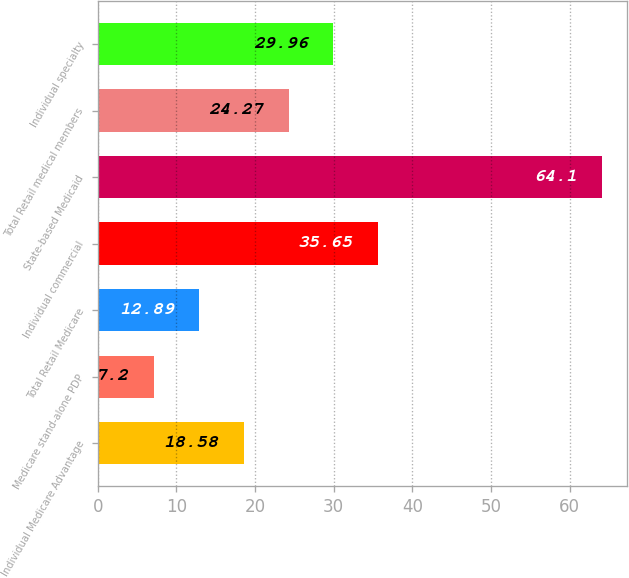Convert chart to OTSL. <chart><loc_0><loc_0><loc_500><loc_500><bar_chart><fcel>Individual Medicare Advantage<fcel>Medicare stand-alone PDP<fcel>Total Retail Medicare<fcel>Individual commercial<fcel>State-based Medicaid<fcel>Total Retail medical members<fcel>Individual specialty<nl><fcel>18.58<fcel>7.2<fcel>12.89<fcel>35.65<fcel>64.1<fcel>24.27<fcel>29.96<nl></chart> 